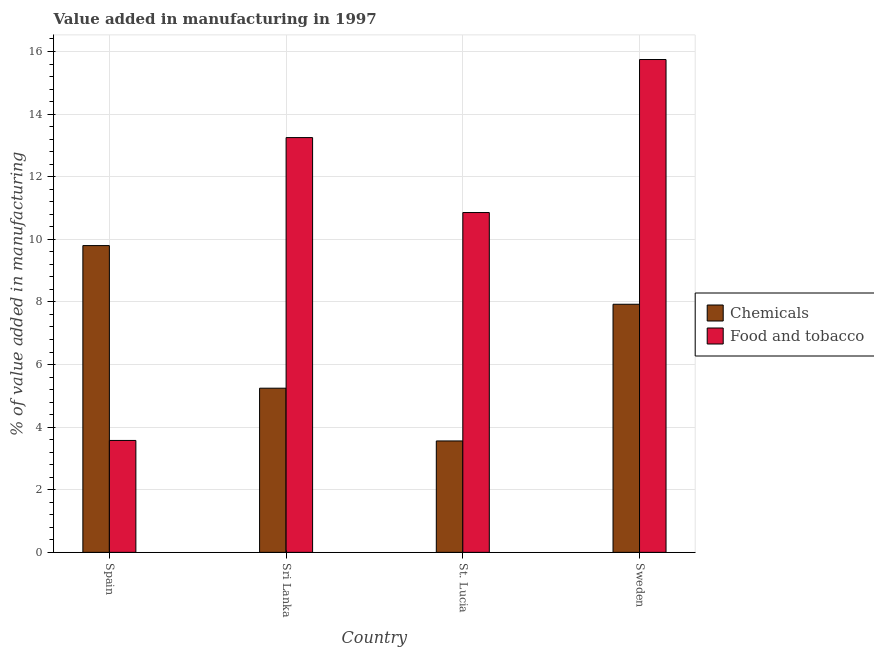How many groups of bars are there?
Provide a short and direct response. 4. Are the number of bars on each tick of the X-axis equal?
Your answer should be compact. Yes. How many bars are there on the 3rd tick from the left?
Make the answer very short. 2. How many bars are there on the 1st tick from the right?
Your answer should be compact. 2. What is the label of the 2nd group of bars from the left?
Give a very brief answer. Sri Lanka. In how many cases, is the number of bars for a given country not equal to the number of legend labels?
Provide a succinct answer. 0. What is the value added by  manufacturing chemicals in Spain?
Give a very brief answer. 9.8. Across all countries, what is the maximum value added by manufacturing food and tobacco?
Provide a succinct answer. 15.74. Across all countries, what is the minimum value added by manufacturing food and tobacco?
Your answer should be compact. 3.57. In which country was the value added by manufacturing food and tobacco maximum?
Provide a short and direct response. Sweden. In which country was the value added by manufacturing food and tobacco minimum?
Provide a short and direct response. Spain. What is the total value added by manufacturing food and tobacco in the graph?
Offer a very short reply. 43.42. What is the difference between the value added by  manufacturing chemicals in Sri Lanka and that in St. Lucia?
Offer a terse response. 1.69. What is the difference between the value added by  manufacturing chemicals in Sri Lanka and the value added by manufacturing food and tobacco in St. Lucia?
Offer a very short reply. -5.61. What is the average value added by  manufacturing chemicals per country?
Your answer should be compact. 6.63. What is the difference between the value added by manufacturing food and tobacco and value added by  manufacturing chemicals in Sri Lanka?
Ensure brevity in your answer.  8.01. In how many countries, is the value added by  manufacturing chemicals greater than 0.8 %?
Provide a succinct answer. 4. What is the ratio of the value added by  manufacturing chemicals in St. Lucia to that in Sweden?
Provide a short and direct response. 0.45. What is the difference between the highest and the second highest value added by  manufacturing chemicals?
Your response must be concise. 1.87. What is the difference between the highest and the lowest value added by manufacturing food and tobacco?
Offer a very short reply. 12.17. In how many countries, is the value added by  manufacturing chemicals greater than the average value added by  manufacturing chemicals taken over all countries?
Offer a very short reply. 2. What does the 2nd bar from the left in Sweden represents?
Offer a terse response. Food and tobacco. What does the 2nd bar from the right in Sweden represents?
Your response must be concise. Chemicals. How many bars are there?
Ensure brevity in your answer.  8. Are all the bars in the graph horizontal?
Keep it short and to the point. No. What is the difference between two consecutive major ticks on the Y-axis?
Offer a very short reply. 2. Are the values on the major ticks of Y-axis written in scientific E-notation?
Keep it short and to the point. No. Does the graph contain any zero values?
Give a very brief answer. No. Where does the legend appear in the graph?
Give a very brief answer. Center right. How many legend labels are there?
Provide a short and direct response. 2. What is the title of the graph?
Make the answer very short. Value added in manufacturing in 1997. What is the label or title of the Y-axis?
Provide a succinct answer. % of value added in manufacturing. What is the % of value added in manufacturing in Chemicals in Spain?
Give a very brief answer. 9.8. What is the % of value added in manufacturing of Food and tobacco in Spain?
Your answer should be compact. 3.57. What is the % of value added in manufacturing of Chemicals in Sri Lanka?
Ensure brevity in your answer.  5.24. What is the % of value added in manufacturing of Food and tobacco in Sri Lanka?
Your response must be concise. 13.25. What is the % of value added in manufacturing in Chemicals in St. Lucia?
Offer a terse response. 3.56. What is the % of value added in manufacturing of Food and tobacco in St. Lucia?
Keep it short and to the point. 10.86. What is the % of value added in manufacturing in Chemicals in Sweden?
Offer a very short reply. 7.93. What is the % of value added in manufacturing of Food and tobacco in Sweden?
Make the answer very short. 15.74. Across all countries, what is the maximum % of value added in manufacturing of Chemicals?
Offer a terse response. 9.8. Across all countries, what is the maximum % of value added in manufacturing in Food and tobacco?
Give a very brief answer. 15.74. Across all countries, what is the minimum % of value added in manufacturing of Chemicals?
Provide a short and direct response. 3.56. Across all countries, what is the minimum % of value added in manufacturing of Food and tobacco?
Make the answer very short. 3.57. What is the total % of value added in manufacturing of Chemicals in the graph?
Your answer should be very brief. 26.53. What is the total % of value added in manufacturing in Food and tobacco in the graph?
Your answer should be compact. 43.42. What is the difference between the % of value added in manufacturing in Chemicals in Spain and that in Sri Lanka?
Provide a succinct answer. 4.56. What is the difference between the % of value added in manufacturing in Food and tobacco in Spain and that in Sri Lanka?
Your answer should be compact. -9.68. What is the difference between the % of value added in manufacturing of Chemicals in Spain and that in St. Lucia?
Provide a short and direct response. 6.24. What is the difference between the % of value added in manufacturing in Food and tobacco in Spain and that in St. Lucia?
Your answer should be compact. -7.28. What is the difference between the % of value added in manufacturing of Chemicals in Spain and that in Sweden?
Provide a succinct answer. 1.87. What is the difference between the % of value added in manufacturing in Food and tobacco in Spain and that in Sweden?
Your answer should be very brief. -12.17. What is the difference between the % of value added in manufacturing of Chemicals in Sri Lanka and that in St. Lucia?
Keep it short and to the point. 1.69. What is the difference between the % of value added in manufacturing in Food and tobacco in Sri Lanka and that in St. Lucia?
Your response must be concise. 2.39. What is the difference between the % of value added in manufacturing of Chemicals in Sri Lanka and that in Sweden?
Provide a succinct answer. -2.68. What is the difference between the % of value added in manufacturing in Food and tobacco in Sri Lanka and that in Sweden?
Keep it short and to the point. -2.49. What is the difference between the % of value added in manufacturing of Chemicals in St. Lucia and that in Sweden?
Your response must be concise. -4.37. What is the difference between the % of value added in manufacturing in Food and tobacco in St. Lucia and that in Sweden?
Make the answer very short. -4.89. What is the difference between the % of value added in manufacturing in Chemicals in Spain and the % of value added in manufacturing in Food and tobacco in Sri Lanka?
Offer a terse response. -3.45. What is the difference between the % of value added in manufacturing of Chemicals in Spain and the % of value added in manufacturing of Food and tobacco in St. Lucia?
Provide a short and direct response. -1.06. What is the difference between the % of value added in manufacturing of Chemicals in Spain and the % of value added in manufacturing of Food and tobacco in Sweden?
Offer a very short reply. -5.94. What is the difference between the % of value added in manufacturing of Chemicals in Sri Lanka and the % of value added in manufacturing of Food and tobacco in St. Lucia?
Your answer should be very brief. -5.61. What is the difference between the % of value added in manufacturing in Chemicals in Sri Lanka and the % of value added in manufacturing in Food and tobacco in Sweden?
Your answer should be very brief. -10.5. What is the difference between the % of value added in manufacturing in Chemicals in St. Lucia and the % of value added in manufacturing in Food and tobacco in Sweden?
Provide a succinct answer. -12.18. What is the average % of value added in manufacturing of Chemicals per country?
Provide a short and direct response. 6.63. What is the average % of value added in manufacturing of Food and tobacco per country?
Your response must be concise. 10.86. What is the difference between the % of value added in manufacturing of Chemicals and % of value added in manufacturing of Food and tobacco in Spain?
Offer a very short reply. 6.22. What is the difference between the % of value added in manufacturing in Chemicals and % of value added in manufacturing in Food and tobacco in Sri Lanka?
Your answer should be very brief. -8.01. What is the difference between the % of value added in manufacturing of Chemicals and % of value added in manufacturing of Food and tobacco in St. Lucia?
Offer a very short reply. -7.3. What is the difference between the % of value added in manufacturing in Chemicals and % of value added in manufacturing in Food and tobacco in Sweden?
Your answer should be compact. -7.82. What is the ratio of the % of value added in manufacturing in Chemicals in Spain to that in Sri Lanka?
Keep it short and to the point. 1.87. What is the ratio of the % of value added in manufacturing of Food and tobacco in Spain to that in Sri Lanka?
Keep it short and to the point. 0.27. What is the ratio of the % of value added in manufacturing of Chemicals in Spain to that in St. Lucia?
Offer a very short reply. 2.75. What is the ratio of the % of value added in manufacturing in Food and tobacco in Spain to that in St. Lucia?
Your response must be concise. 0.33. What is the ratio of the % of value added in manufacturing of Chemicals in Spain to that in Sweden?
Provide a short and direct response. 1.24. What is the ratio of the % of value added in manufacturing of Food and tobacco in Spain to that in Sweden?
Offer a very short reply. 0.23. What is the ratio of the % of value added in manufacturing in Chemicals in Sri Lanka to that in St. Lucia?
Your answer should be compact. 1.47. What is the ratio of the % of value added in manufacturing in Food and tobacco in Sri Lanka to that in St. Lucia?
Provide a short and direct response. 1.22. What is the ratio of the % of value added in manufacturing of Chemicals in Sri Lanka to that in Sweden?
Provide a succinct answer. 0.66. What is the ratio of the % of value added in manufacturing in Food and tobacco in Sri Lanka to that in Sweden?
Give a very brief answer. 0.84. What is the ratio of the % of value added in manufacturing of Chemicals in St. Lucia to that in Sweden?
Your response must be concise. 0.45. What is the ratio of the % of value added in manufacturing in Food and tobacco in St. Lucia to that in Sweden?
Make the answer very short. 0.69. What is the difference between the highest and the second highest % of value added in manufacturing in Chemicals?
Your answer should be very brief. 1.87. What is the difference between the highest and the second highest % of value added in manufacturing of Food and tobacco?
Offer a terse response. 2.49. What is the difference between the highest and the lowest % of value added in manufacturing in Chemicals?
Provide a short and direct response. 6.24. What is the difference between the highest and the lowest % of value added in manufacturing of Food and tobacco?
Keep it short and to the point. 12.17. 